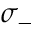Convert formula to latex. <formula><loc_0><loc_0><loc_500><loc_500>\sigma _ { - }</formula> 